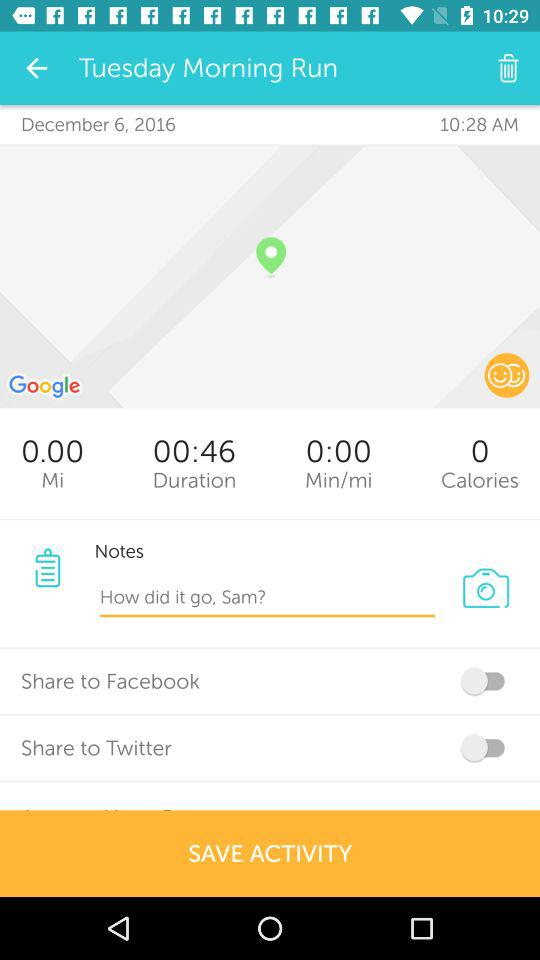What is the status of "Share to Twitter"? The status of "Share to Twitter" is "off". 